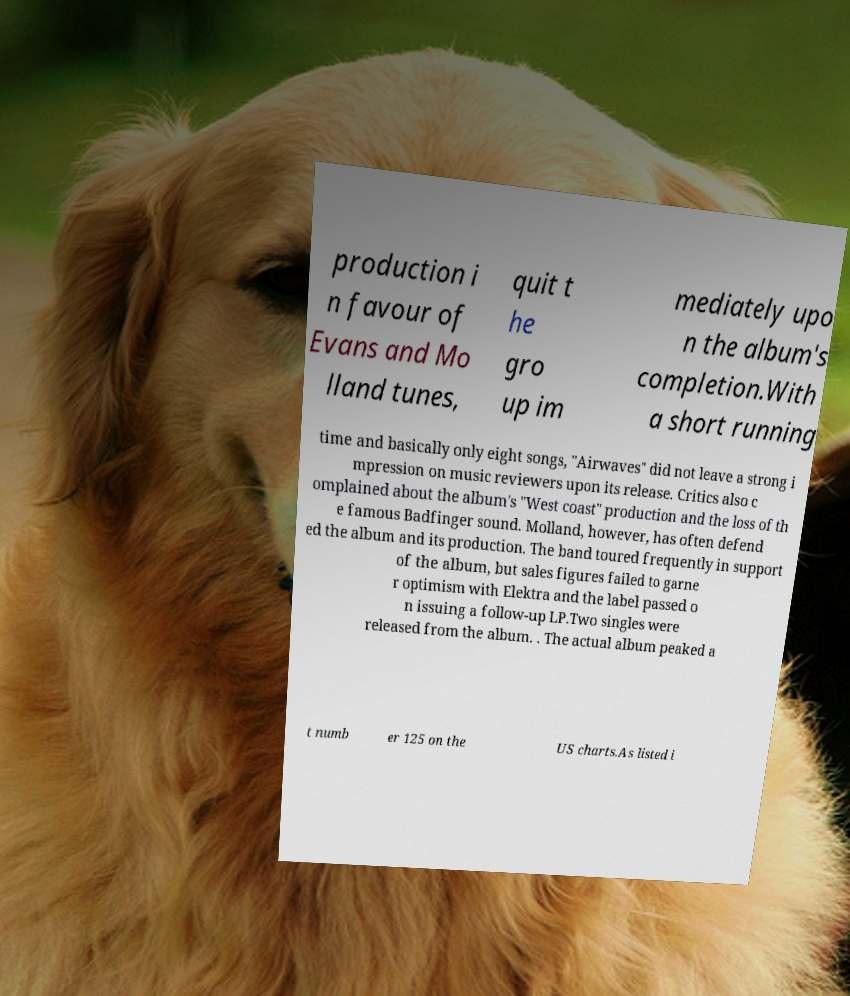Can you read and provide the text displayed in the image?This photo seems to have some interesting text. Can you extract and type it out for me? production i n favour of Evans and Mo lland tunes, quit t he gro up im mediately upo n the album's completion.With a short running time and basically only eight songs, "Airwaves" did not leave a strong i mpression on music reviewers upon its release. Critics also c omplained about the album's "West coast" production and the loss of th e famous Badfinger sound. Molland, however, has often defend ed the album and its production. The band toured frequently in support of the album, but sales figures failed to garne r optimism with Elektra and the label passed o n issuing a follow-up LP.Two singles were released from the album. . The actual album peaked a t numb er 125 on the US charts.As listed i 